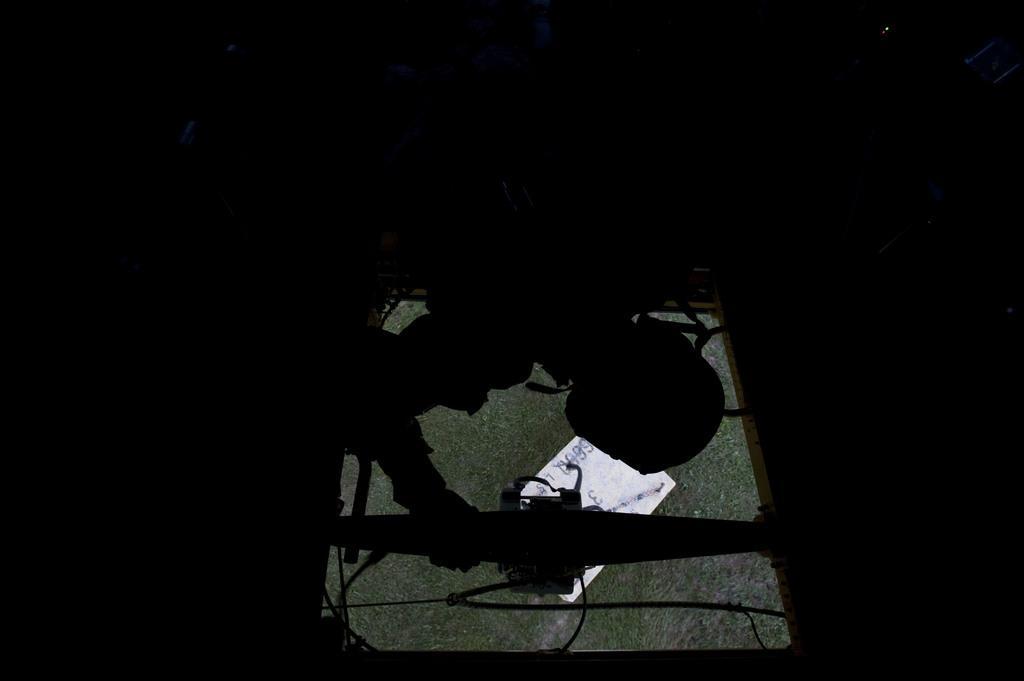In one or two sentences, can you explain what this image depicts? In this image in the front there is a person holding a window and behind the window there's grass on the ground and there is an object which is white in colour. 